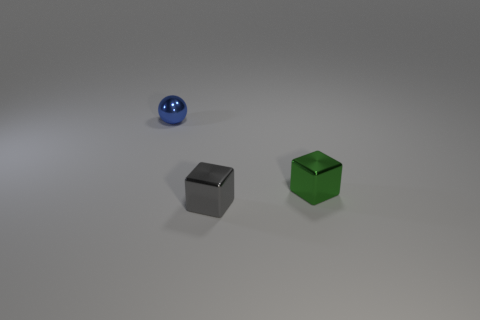There is a small cube to the left of the green block; what material is it?
Offer a terse response. Metal. Are the block to the right of the small gray metal object and the blue ball made of the same material?
Your response must be concise. Yes. There is a gray thing that is the same size as the green metal object; what shape is it?
Provide a succinct answer. Cube. Is the number of tiny balls on the left side of the small green cube less than the number of small spheres that are to the left of the blue ball?
Your response must be concise. No. Are there any objects to the left of the tiny metallic sphere?
Give a very brief answer. No. Are there any metallic balls that are to the right of the tiny metallic object that is to the right of the tiny cube that is in front of the green object?
Keep it short and to the point. No. There is a tiny metallic object that is on the right side of the small gray thing; does it have the same shape as the gray object?
Make the answer very short. Yes. What is the color of the tiny ball that is made of the same material as the small gray cube?
Ensure brevity in your answer.  Blue. How many other tiny blue balls have the same material as the blue sphere?
Keep it short and to the point. 0. There is a block that is in front of the green metallic object that is on the right side of the object in front of the green metallic thing; what color is it?
Offer a very short reply. Gray. 